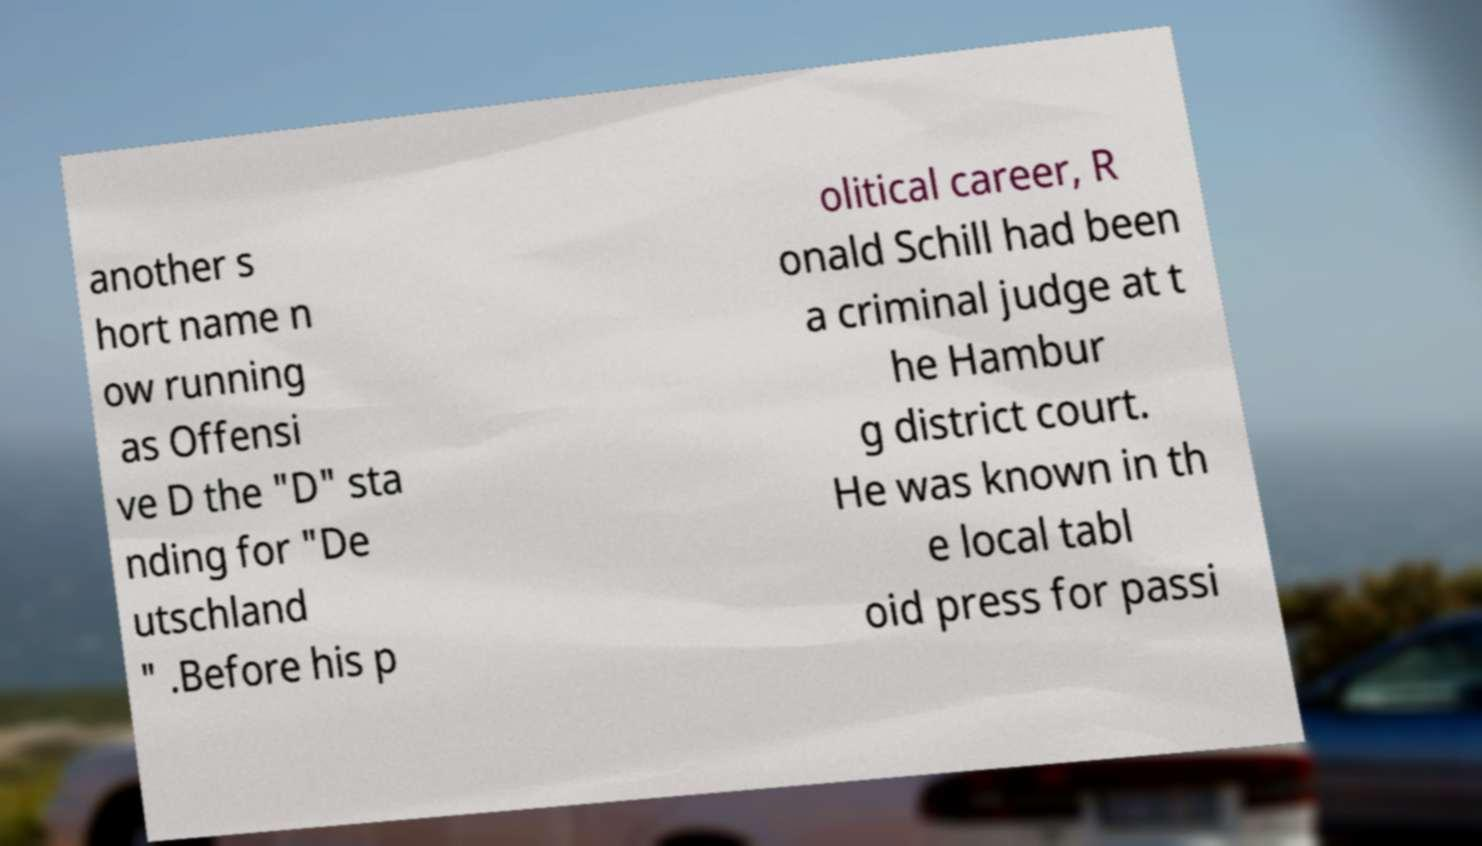I need the written content from this picture converted into text. Can you do that? another s hort name n ow running as Offensi ve D the "D" sta nding for "De utschland " .Before his p olitical career, R onald Schill had been a criminal judge at t he Hambur g district court. He was known in th e local tabl oid press for passi 